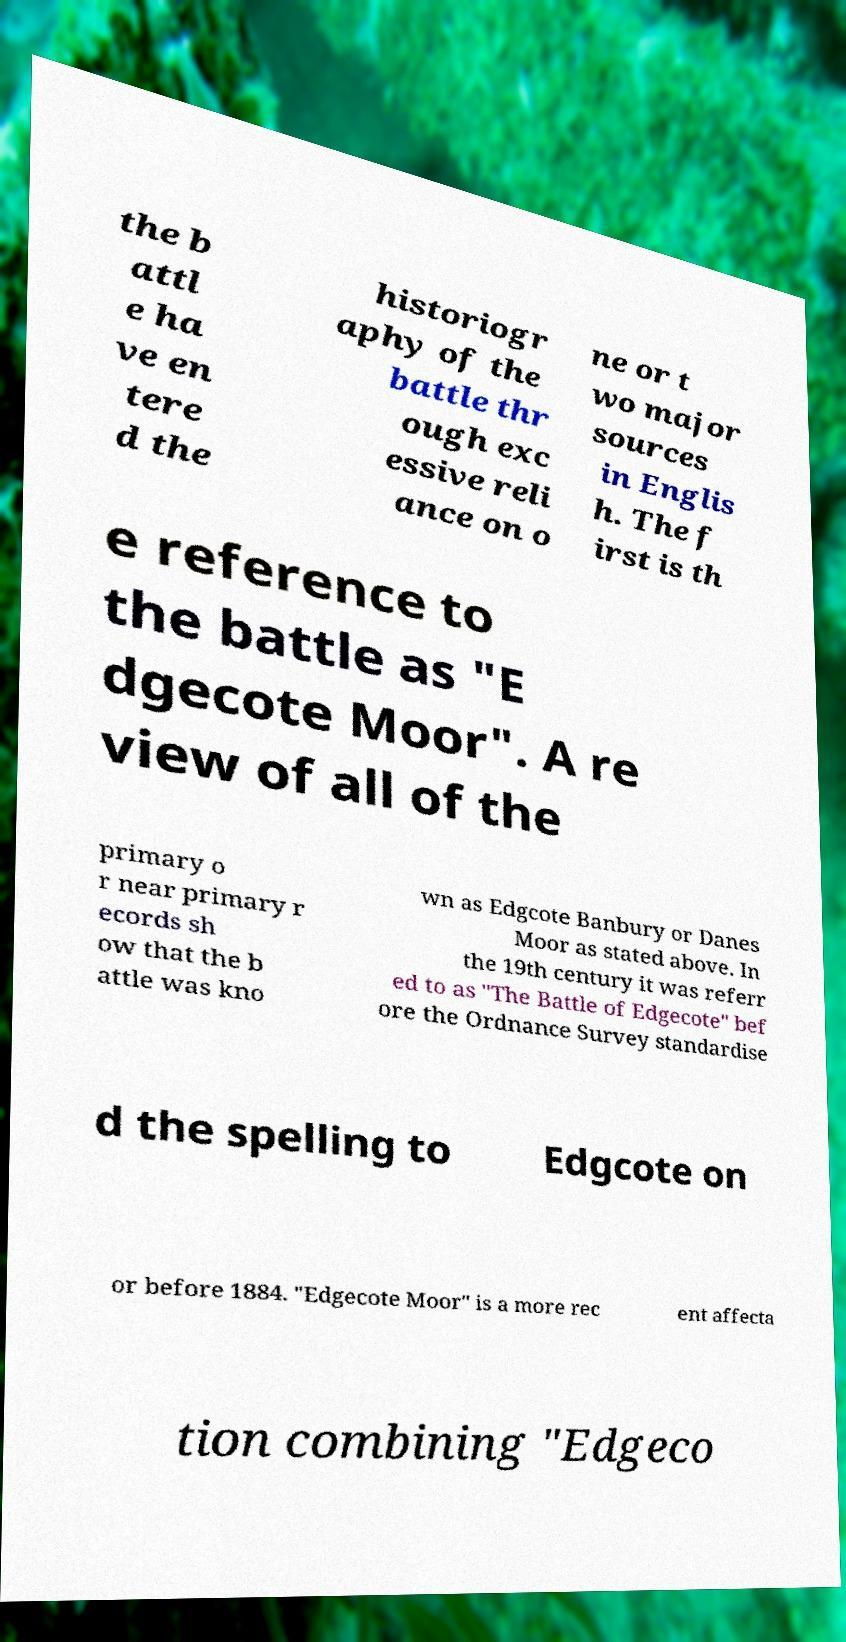Can you accurately transcribe the text from the provided image for me? the b attl e ha ve en tere d the historiogr aphy of the battle thr ough exc essive reli ance on o ne or t wo major sources in Englis h. The f irst is th e reference to the battle as "E dgecote Moor". A re view of all of the primary o r near primary r ecords sh ow that the b attle was kno wn as Edgcote Banbury or Danes Moor as stated above. In the 19th century it was referr ed to as "The Battle of Edgecote" bef ore the Ordnance Survey standardise d the spelling to Edgcote on or before 1884. "Edgecote Moor" is a more rec ent affecta tion combining "Edgeco 